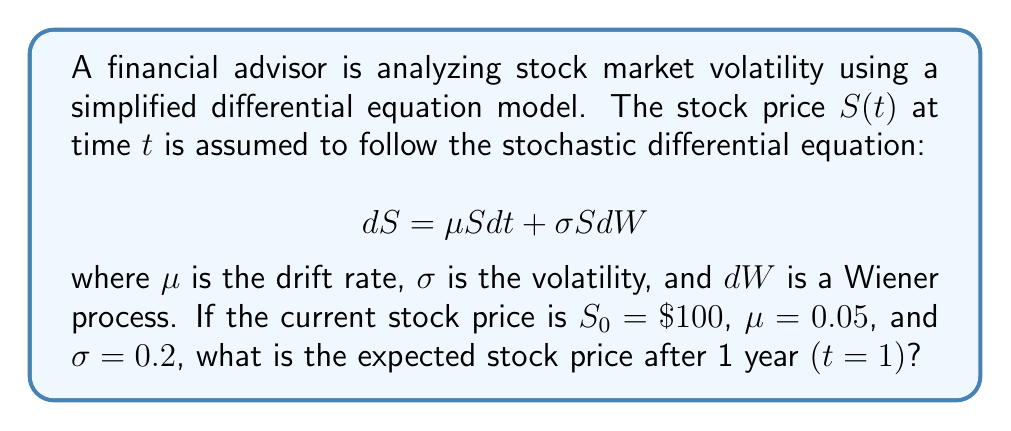Can you answer this question? To solve this problem, we need to use Itô's lemma and the properties of the geometric Brownian motion model:

1) The solution to the stochastic differential equation is given by:

   $$S(t) = S_0 \exp\left(\left(\mu - \frac{\sigma^2}{2}\right)t + \sigma W(t)\right)$$

2) For the expected value, we can use the property that $E[e^{\sigma W(t)}] = e^{\frac{\sigma^2 t}{2}}$. Therefore, the expected value of $S(t)$ is:

   $$E[S(t)] = S_0 \exp(\mu t)$$

3) Plugging in the given values:
   $S_0 = 100$
   $\mu = 0.05$
   $t = 1$

4) Calculate:
   $$E[S(1)] = 100 \exp(0.05 \cdot 1) = 100 e^{0.05} \approx 105.13$$

Note that while the volatility $\sigma$ appears in the full stochastic equation, it doesn't affect the expected value directly. However, it would impact the variance of the stock price distribution.
Answer: The expected stock price after 1 year is approximately $105.13. 